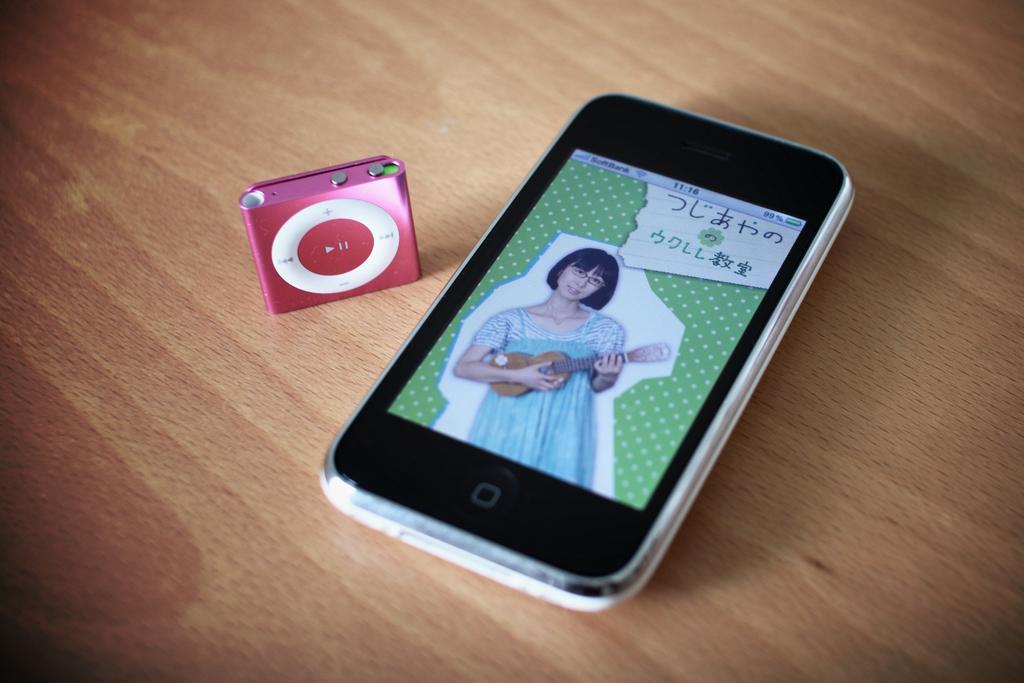Could you give a brief overview of what you see in this image? In a picture there is one mobile and ipad. 